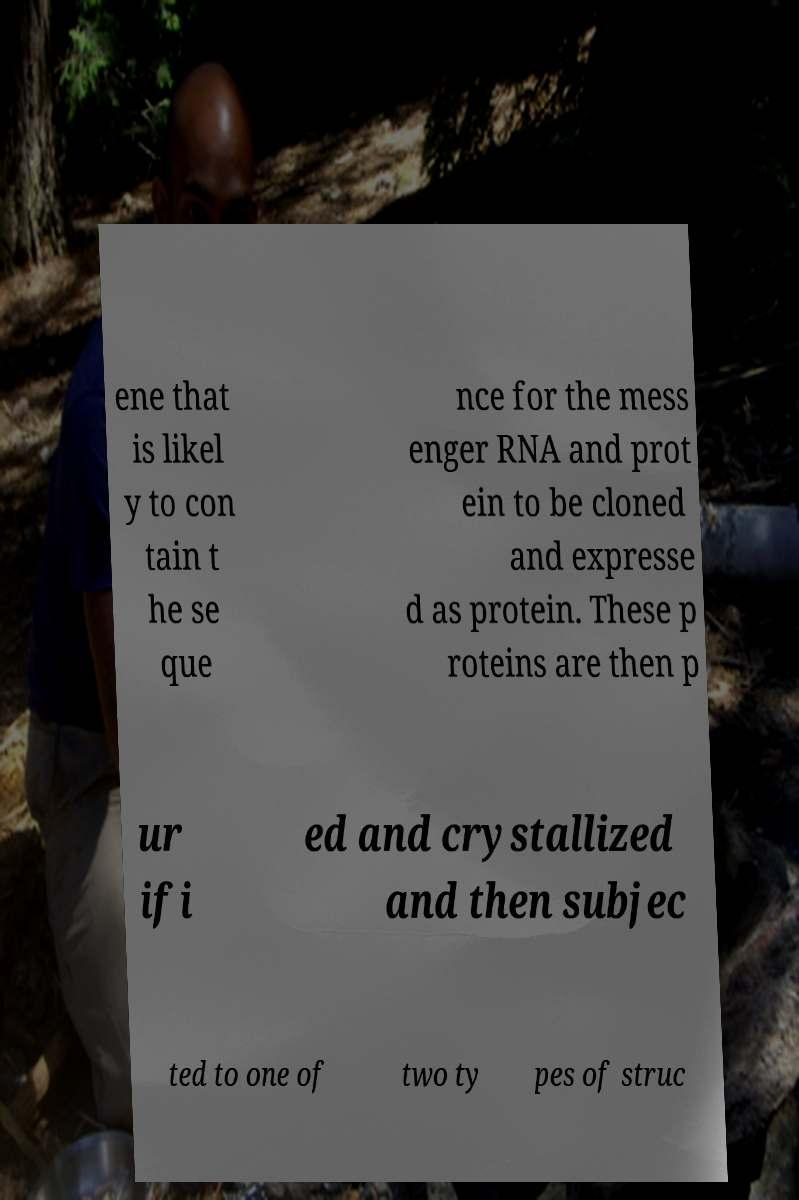Could you extract and type out the text from this image? ene that is likel y to con tain t he se que nce for the mess enger RNA and prot ein to be cloned and expresse d as protein. These p roteins are then p ur ifi ed and crystallized and then subjec ted to one of two ty pes of struc 